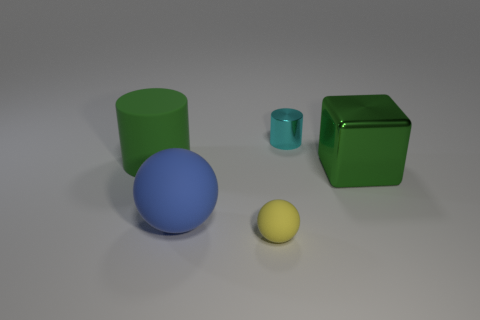Are there any other things that have the same shape as the big metal thing?
Your response must be concise. No. What is the color of the thing behind the large green thing that is to the left of the cylinder that is right of the blue sphere?
Your answer should be compact. Cyan. Are the small sphere and the tiny cyan object made of the same material?
Offer a very short reply. No. What number of things are in front of the rubber cylinder?
Keep it short and to the point. 3. There is another thing that is the same shape as the tiny metallic thing; what is its size?
Keep it short and to the point. Large. What number of green things are spheres or small metallic cylinders?
Ensure brevity in your answer.  0. What number of tiny yellow matte spheres are in front of the green thing that is on the right side of the tiny cyan metallic cylinder?
Make the answer very short. 1. How many other things are there of the same shape as the big blue matte object?
Make the answer very short. 1. There is a object that is the same color as the metal block; what is its material?
Provide a short and direct response. Rubber. What number of big cylinders have the same color as the metallic cube?
Provide a short and direct response. 1. 